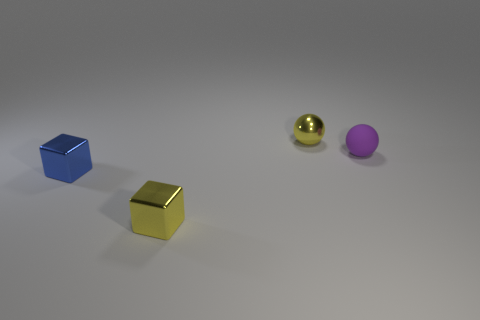The small yellow thing that is behind the yellow object in front of the small blue metallic block is made of what material?
Your response must be concise. Metal. Is the number of small yellow metal spheres that are on the right side of the small rubber ball less than the number of small shiny objects?
Your answer should be very brief. Yes. The blue thing that is made of the same material as the yellow sphere is what shape?
Provide a succinct answer. Cube. How many red objects are tiny rubber things or tiny shiny balls?
Offer a terse response. 0. Does the small rubber thing have the same shape as the small blue thing?
Offer a very short reply. No. Is there a yellow metal thing that is on the left side of the yellow metallic object that is in front of the tiny metallic sphere?
Provide a short and direct response. No. Is the number of metallic cubes that are behind the tiny blue object the same as the number of tiny yellow metal blocks?
Make the answer very short. No. What number of other things are there of the same size as the yellow block?
Your answer should be very brief. 3. Do the small thing that is in front of the tiny blue object and the tiny sphere in front of the small yellow sphere have the same material?
Ensure brevity in your answer.  No. There is a cube behind the yellow metallic object that is in front of the small yellow ball; what is its size?
Offer a terse response. Small. 